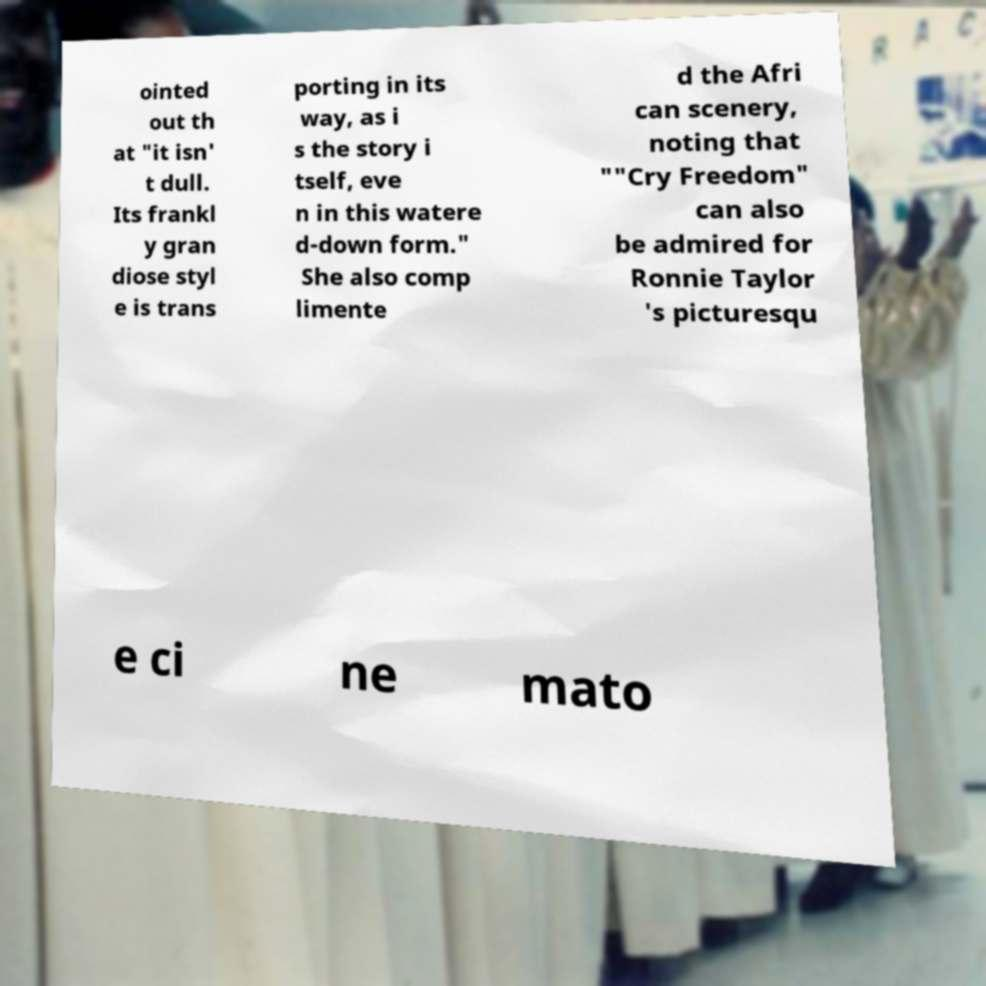Please read and relay the text visible in this image. What does it say? ointed out th at "it isn' t dull. Its frankl y gran diose styl e is trans porting in its way, as i s the story i tself, eve n in this watere d-down form." She also comp limente d the Afri can scenery, noting that ""Cry Freedom" can also be admired for Ronnie Taylor 's picturesqu e ci ne mato 